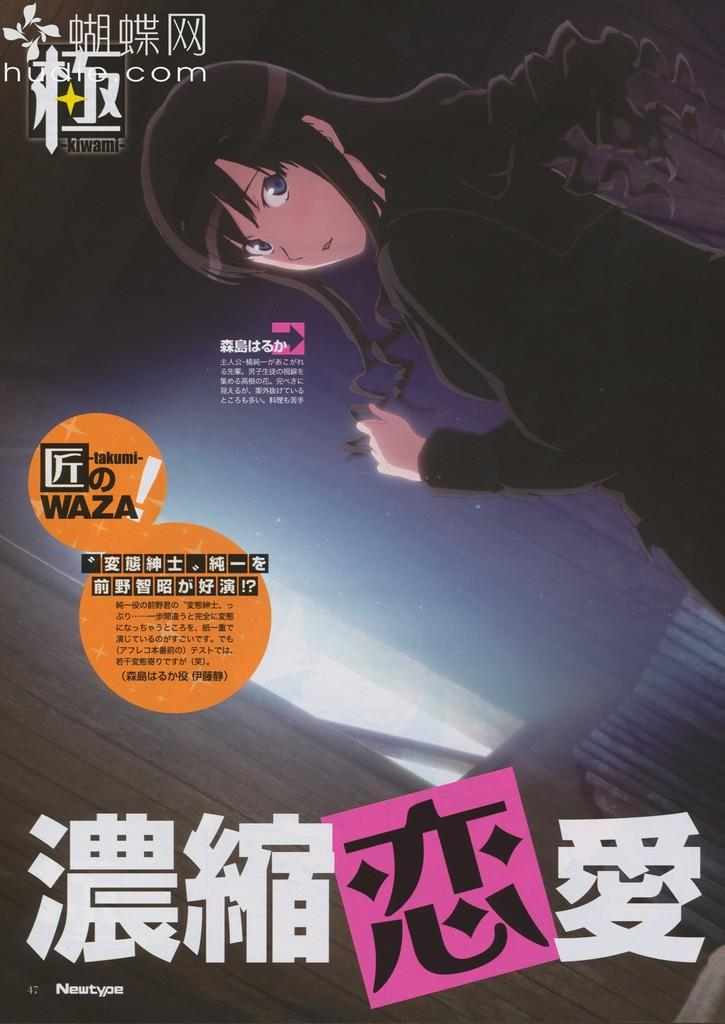What is the main subject of the image? There is an animation of a woman in the image. What else can be seen in the image besides the woman? There is text in the image. What can be observed in the background of the image? There are rays of light in the background of the image. How many trees are visible in the image? There are no trees visible in the image; it features an animation of a woman, text, and rays of light in the background. 